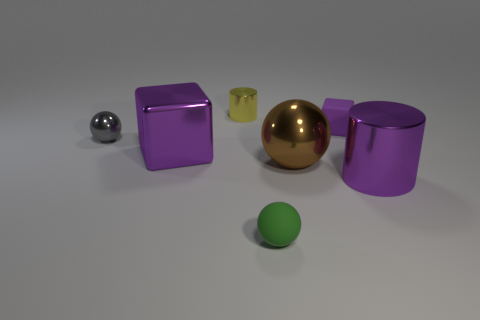Add 3 matte blocks. How many objects exist? 10 Subtract all cylinders. How many objects are left? 5 Add 2 yellow cylinders. How many yellow cylinders exist? 3 Subtract 0 red cylinders. How many objects are left? 7 Subtract all tiny purple rubber blocks. Subtract all yellow cylinders. How many objects are left? 5 Add 2 purple cylinders. How many purple cylinders are left? 3 